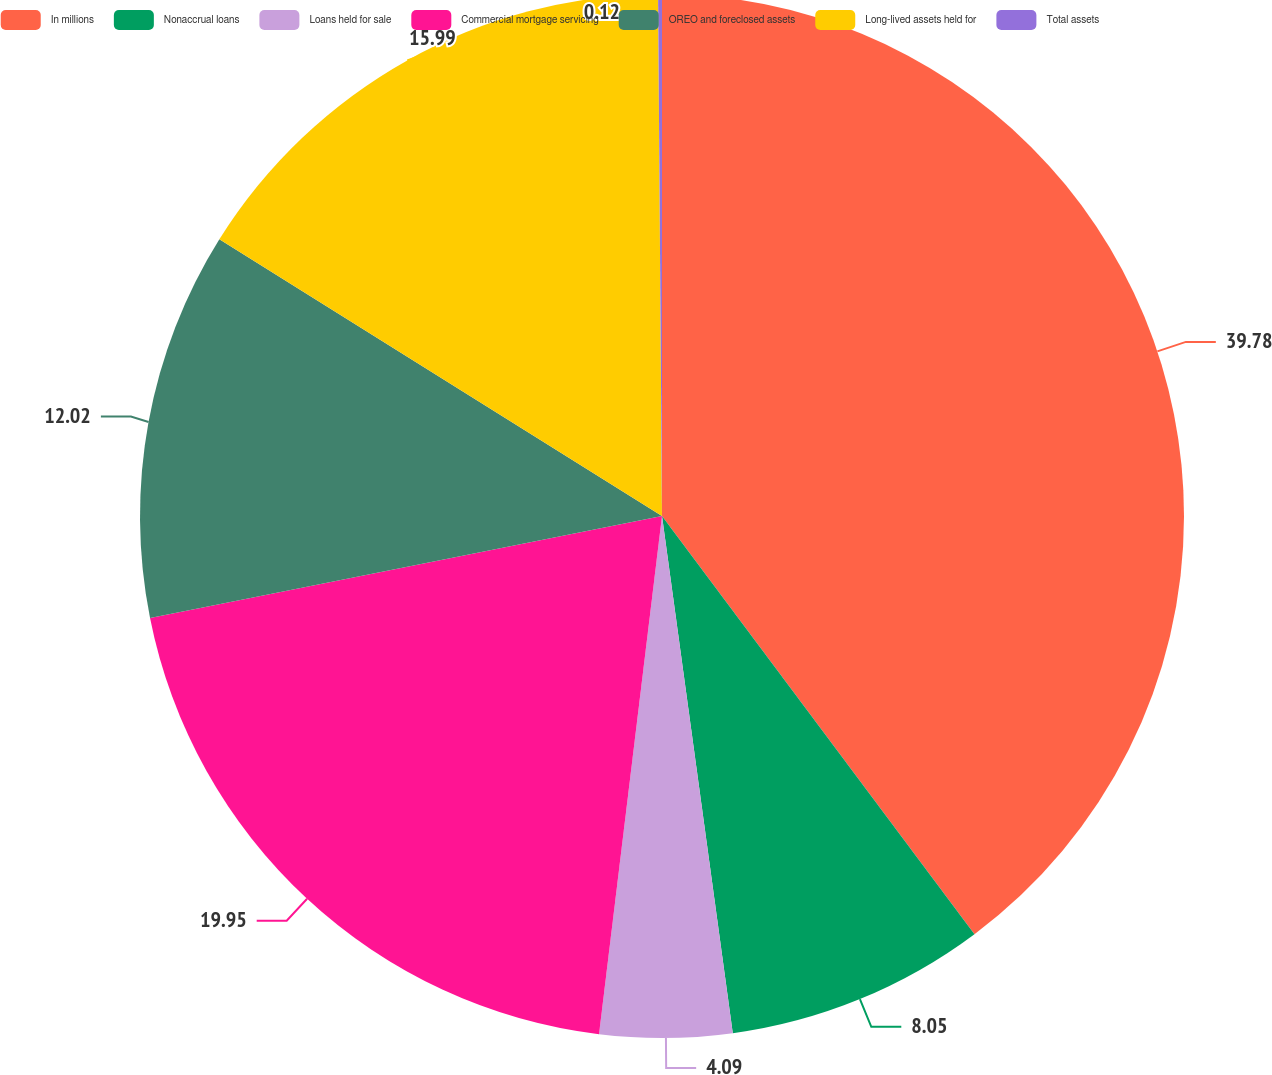<chart> <loc_0><loc_0><loc_500><loc_500><pie_chart><fcel>In millions<fcel>Nonaccrual loans<fcel>Loans held for sale<fcel>Commercial mortgage servicing<fcel>OREO and foreclosed assets<fcel>Long-lived assets held for<fcel>Total assets<nl><fcel>39.79%<fcel>8.05%<fcel>4.09%<fcel>19.95%<fcel>12.02%<fcel>15.99%<fcel>0.12%<nl></chart> 